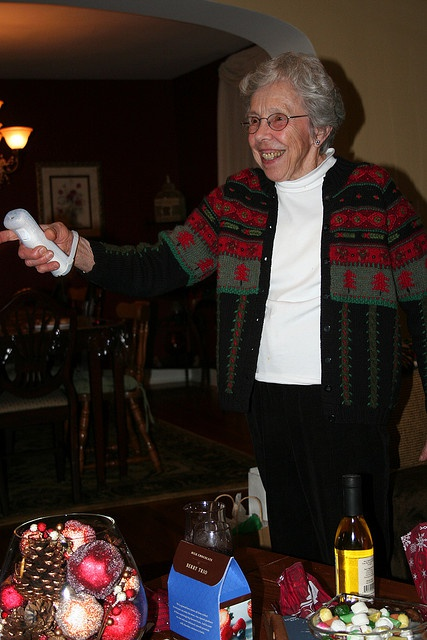Describe the objects in this image and their specific colors. I can see people in black, lightgray, maroon, and brown tones, chair in black, maroon, and gray tones, chair in black, maroon, and gray tones, bowl in black, lightgray, gray, and maroon tones, and bottle in black, gold, maroon, and lightgray tones in this image. 